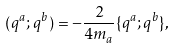Convert formula to latex. <formula><loc_0><loc_0><loc_500><loc_500>( q ^ { a } ; q ^ { b } ) = - \frac { 2 } { 4 m _ { a } } \{ q ^ { a } ; q ^ { b } \} ,</formula> 